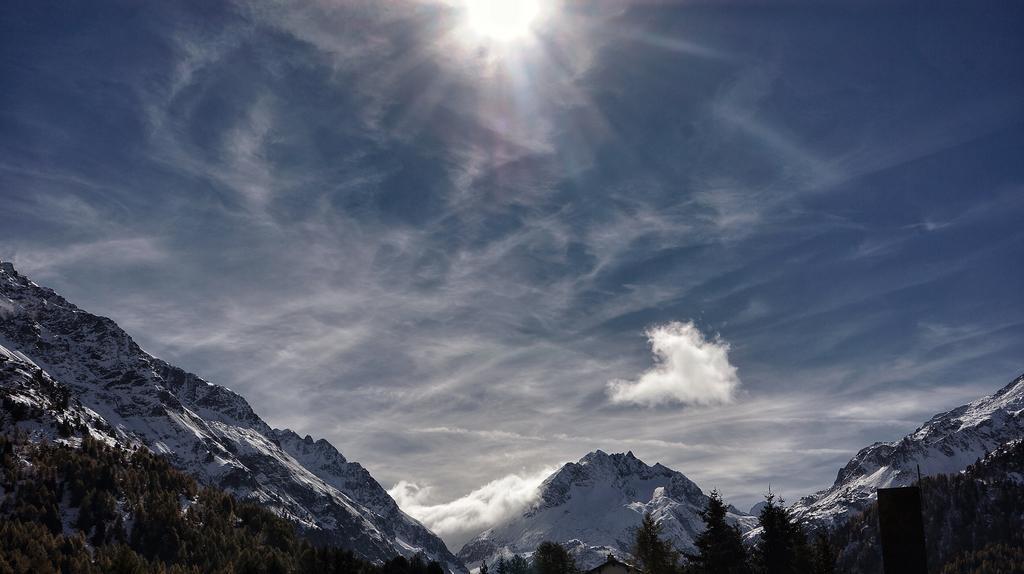Please provide a concise description of this image. In this image, we can see there are trees and snow on the mountains. In the background, there are clouds and sun in the sky. 